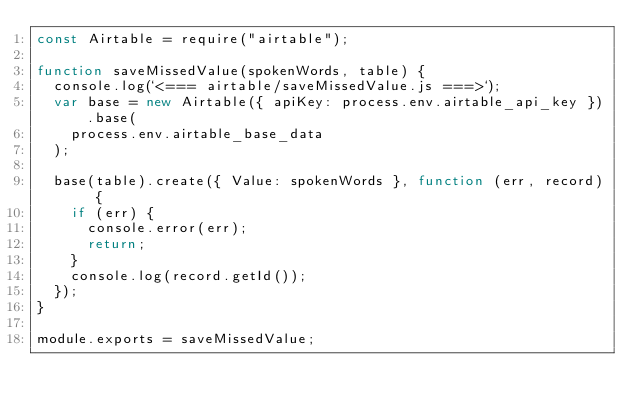Convert code to text. <code><loc_0><loc_0><loc_500><loc_500><_JavaScript_>const Airtable = require("airtable");

function saveMissedValue(spokenWords, table) {
  console.log(`<=== airtable/saveMissedValue.js ===>`);
  var base = new Airtable({ apiKey: process.env.airtable_api_key }).base(
    process.env.airtable_base_data
  );

  base(table).create({ Value: spokenWords }, function (err, record) {
    if (err) {
      console.error(err);
      return;
    }
    console.log(record.getId());
  });
}

module.exports = saveMissedValue;
</code> 